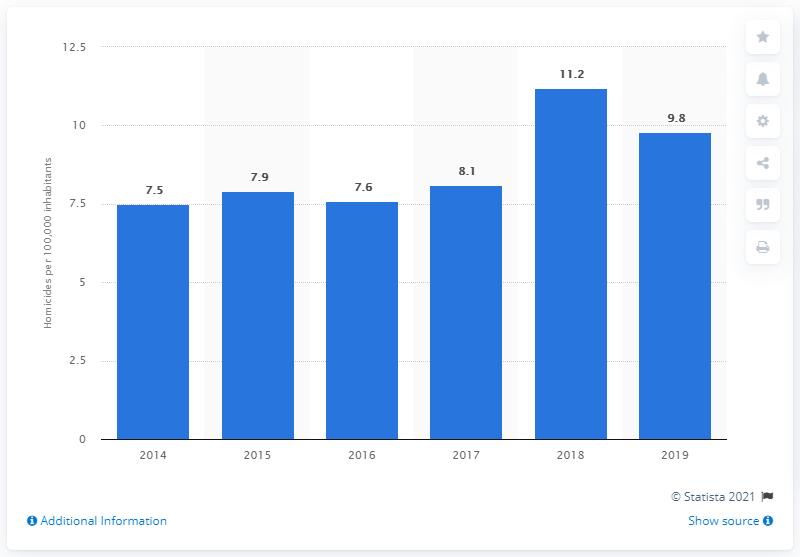Identify some key points in this picture. In the year 2014, Uruguay reported the lowest homicide rate. Uruguay's homicide rate was 11.2 a year earlier. In 2019, the homicide rate in Uruguay was 9.8 per 100,000 inhabitants. 